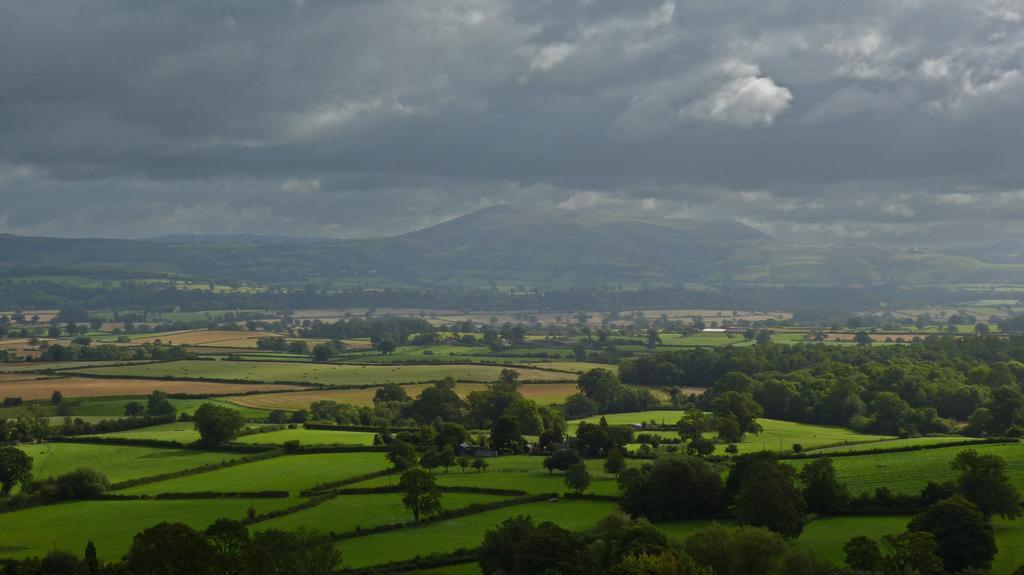Describe this image in one or two sentences. In the foreground of the picture there are trees and fields. In the background there are fields, trees and hills. Sky is cloudy. 